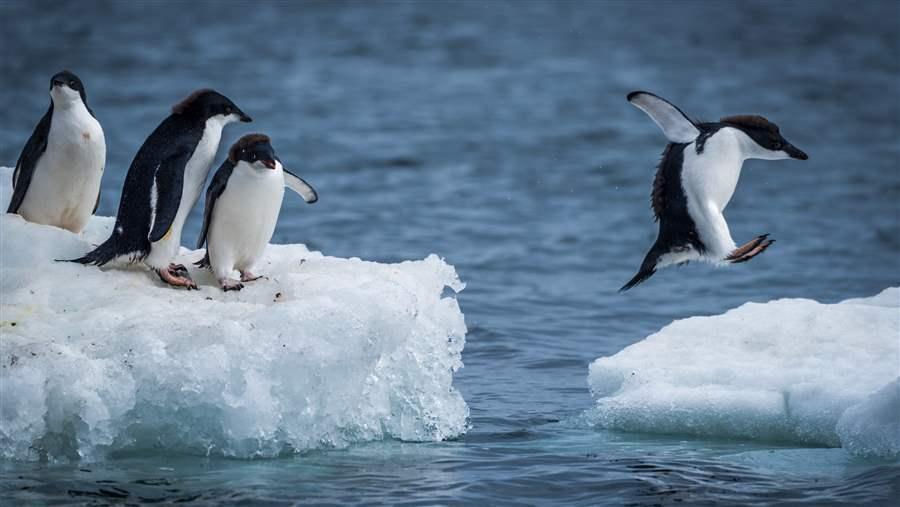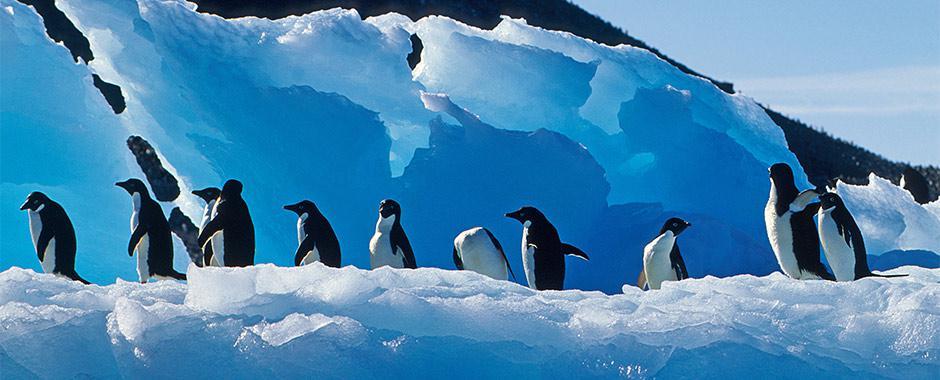The first image is the image on the left, the second image is the image on the right. Analyze the images presented: Is the assertion "One of the images depicts exactly three penguins." valid? Answer yes or no. No. 